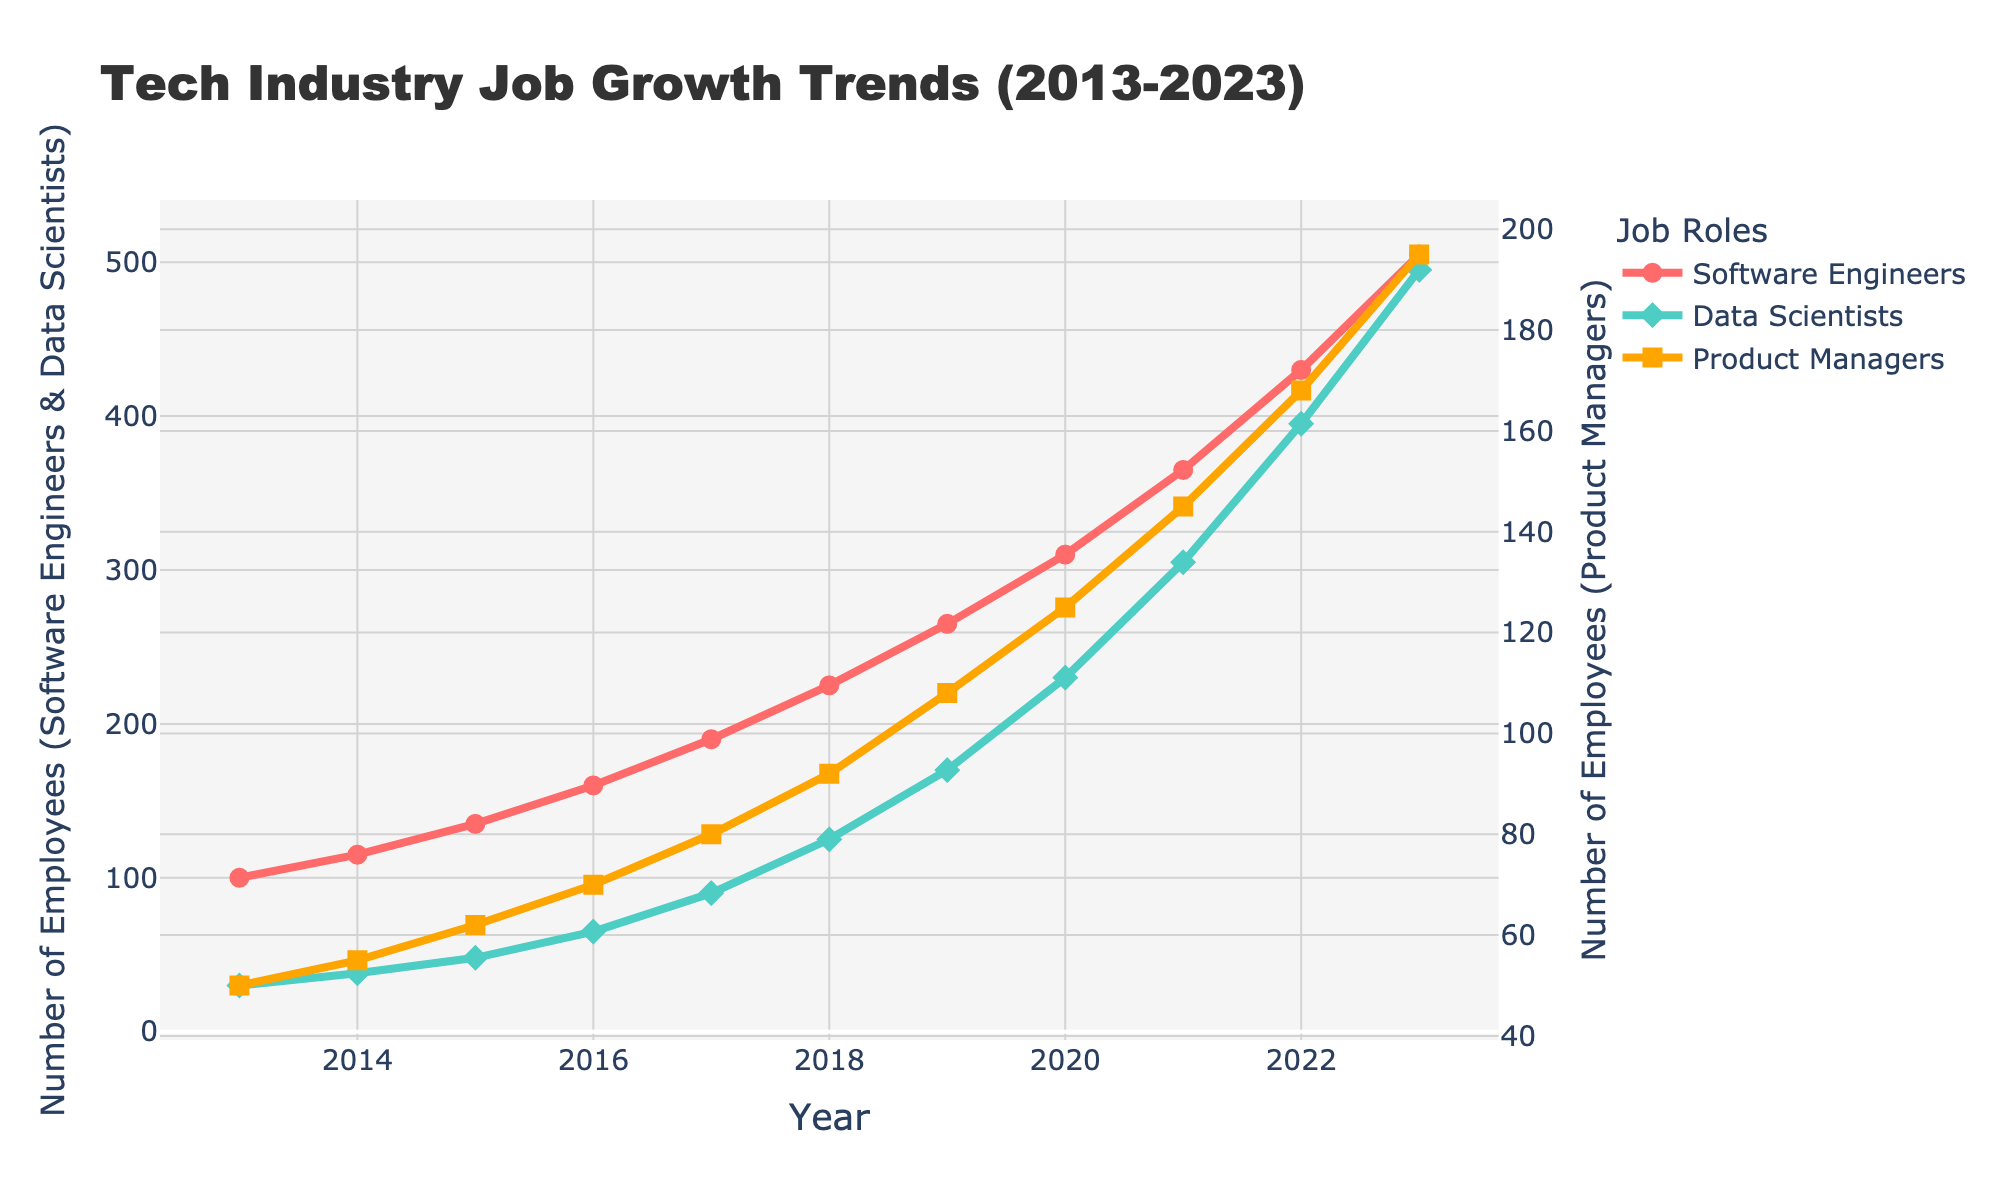What was the job growth rate for Software Engineers from 2013 to 2023? The job growth rate is calculated by finding the difference in the number of employees from 2023 and 2013 and then dividing by the number of employees in 2013. This gives (505 - 100) / 100 = 4.05. Therefore, the job growth rate for Software Engineers from 2013 to 2023 is 405%.
Answer: 405% Which role had the highest number of employees in 2023? By looking at the endpoints of the lines on the graph, it is clear that Software Engineers had the highest number of employees in 2023. The value for Software Engineers is 505, for Data Scientists it is 495, and for Product Managers, it is 195.
Answer: Software Engineers How does the growth trend of Data Scientists compare to that of Product Managers between 2019 and 2022? To compare the trends, examine the slopes of the lines representing Data Scientists and Product Managers between 2019 and 2022. The slope for Data Scientists is steeper, suggesting a faster growth rate. Data Scientist numbers increased from 170 to 395 (+225), whereas Product Managers increased from 108 to 168 (+60).
Answer: Data Scientists grew faster What is the combined number of Data Scientists and Product Managers in 2020? To compute this, add the number of Data Scientists and Product Managers for 2020. The values are 230 for Data Scientists and 125 for Product Managers, so their combined number is 230 + 125 = 355.
Answer: 355 How many more Software Engineers were there than Data Scientists in 2016? To find the difference, subtract the number of Data Scientists from the number of Software Engineers for 2016. Software Engineers in 2016 were 160, and Data Scientists were 65. The difference is 160 - 65 = 95.
Answer: 95 Which year did Product Managers experience the smallest increase compared to the previous year? By examining the graph, one can determine the year with the smallest vertical distance (height) between consecutive points for Product Managers. The smallest increase is from 2015 (62) to 2016 (70), which is an increase of 8.
Answer: 2015 to 2016 What is the percentage increase in the number of Data Scientists from 2018 to 2022? First, find the difference in the number of Data Scientists between 2022 and 2018, which is 395 - 125 = 270. Then, divide by the initial value (125) and multiply by 100 to get the percentage: (270 / 125) * 100 = 216%.
Answer: 216% Between 2017 and 2018, which role saw the greatest increase in absolute numbers? Looking at the figure, compute the changes between 2017 and 2018 for all roles. Software Engineers increased from 190 to 225 (+35), Data Scientists from 90 to 125 (+35), and Product Managers from 80 to 92 (+12). Software Engineers and Data Scientists both had the greatest increase of 35.
Answer: Software Engineers and Data Scientists 